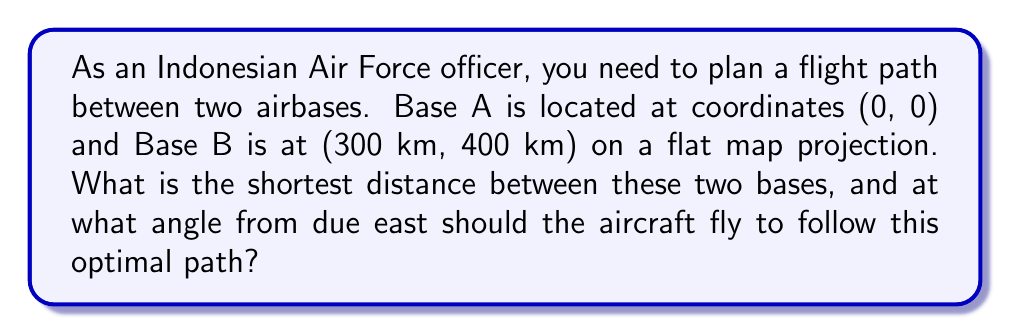Solve this math problem. To solve this problem, we'll use the principles of the Cartesian coordinate system and basic trigonometry.

1. Visualize the problem:
   [asy]
   import geometry;
   
   size(200);
   
   pair A = (0,0);
   pair B = (3,4);
   
   draw((0,0)--(5,0), arrow=Arrow());
   draw((0,0)--(0,5), arrow=Arrow());
   
   dot("A (0, 0)", A, SW);
   dot("B (300, 400)", B, NE);
   
   draw(A--B, red);
   
   label("300 km", (1.5,0), S);
   label("400 km", (3,2), E);
   label("$\theta$", (0.5,0.2), NW);
   [/asy]

2. Calculate the shortest distance:
   The shortest path between two points is a straight line. We can find this using the Pythagorean theorem:

   $$d = \sqrt{(x_2 - x_1)^2 + (y_2 - y_1)^2}$$
   $$d = \sqrt{(300 - 0)^2 + (400 - 0)^2}$$
   $$d = \sqrt{300^2 + 400^2}$$
   $$d = \sqrt{90,000 + 160,000}$$
   $$d = \sqrt{250,000}$$
   $$d = 500 \text{ km}$$

3. Calculate the angle:
   To find the angle from due east, we can use the arctangent function:

   $$\theta = \arctan(\frac{y_2 - y_1}{x_2 - x_1})$$
   $$\theta = \arctan(\frac{400}{300})$$
   $$\theta = \arctan(\frac{4}{3})$$
   $$\theta \approx 53.13^\circ$$

Therefore, the optimal flight path is a straight line of 500 km at an angle of approximately 53.13° from due east.
Answer: 500 km; 53.13° 